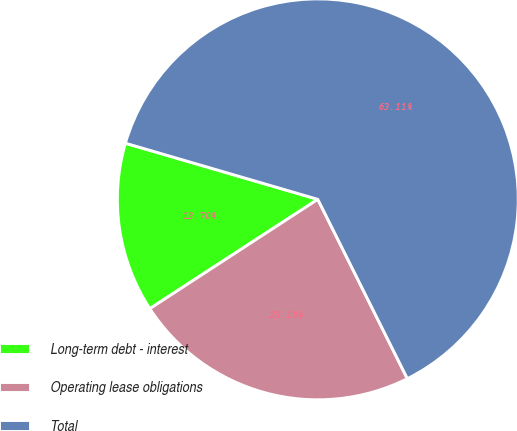Convert chart. <chart><loc_0><loc_0><loc_500><loc_500><pie_chart><fcel>Long-term debt - interest<fcel>Operating lease obligations<fcel>Total<nl><fcel>13.7%<fcel>23.19%<fcel>63.11%<nl></chart> 